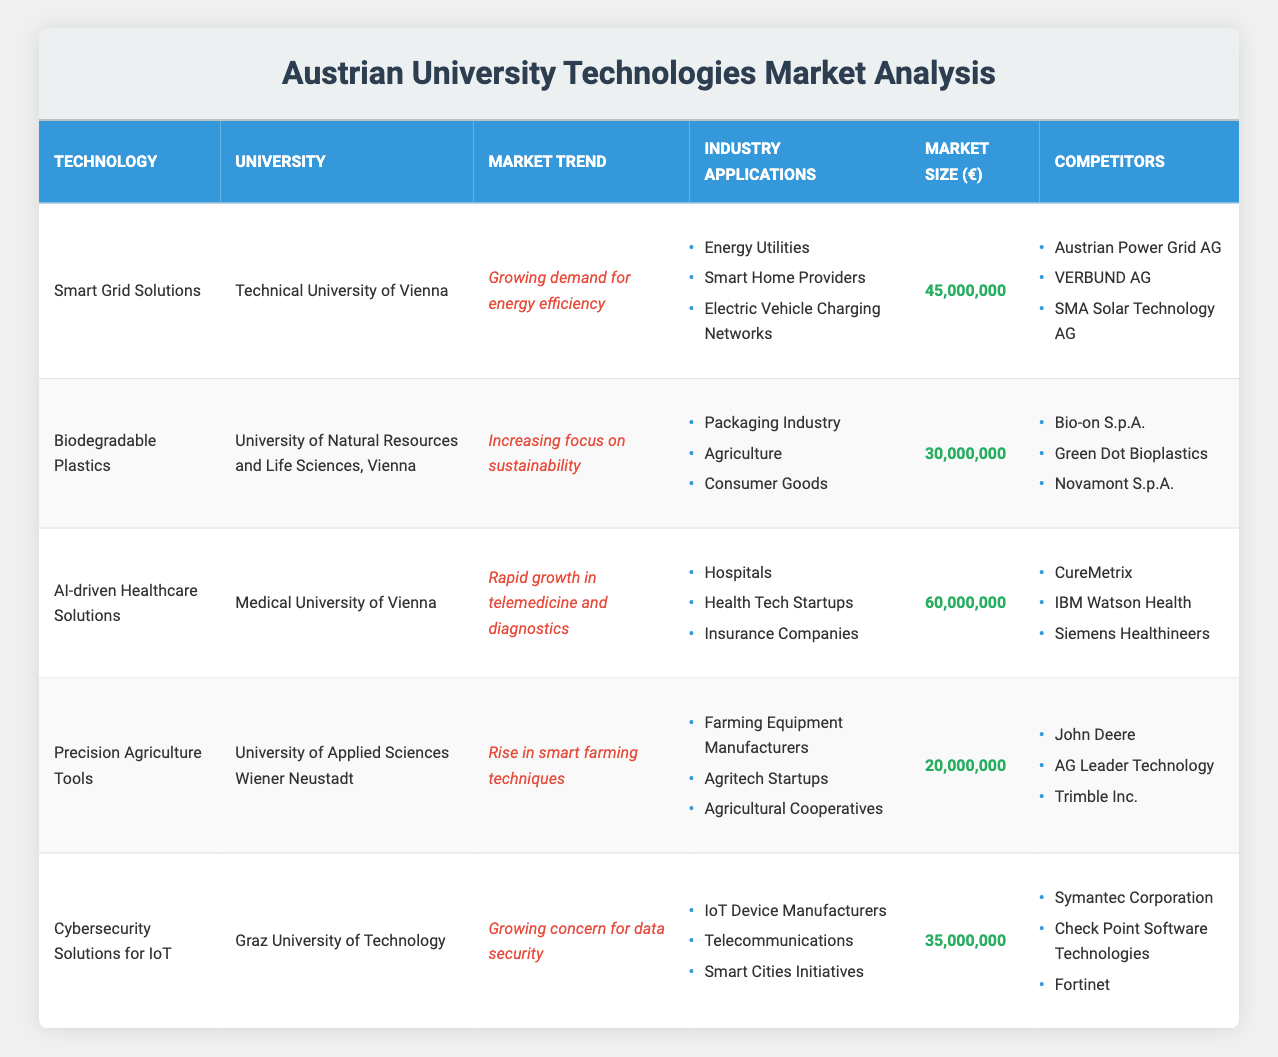What is the estimated market size for AI-driven Healthcare Solutions? The table indicates that the estimated market size for AI-driven Healthcare Solutions, associated with the Medical University of Vienna, is listed under the "Market Size (€)" column as 60,000,000 euros.
Answer: 60,000,000 Which technology has the highest estimated market size? By comparing the "Market Size (€)" values across all technologies, we find that AI-driven Healthcare Solutions has the highest estimated market size of 60,000,000 euros.
Answer: AI-driven Healthcare Solutions Is the market trend for Biodegradable Plastics focused on sustainability? Looking at the "Market Trend" column for Biodegradable Plastics, it specifies "Increasing focus on sustainability," confirming that the statement is true.
Answer: Yes How many competitors are listed for Cybersecurity Solutions for IoT? For Cybersecurity Solutions for IoT, there are three competitors listed under the "Competitors" column: Symantec Corporation, Check Point Software Technologies, and Fortinet, which means the answer is based on counting the entries.
Answer: 3 What is the total estimated market size of Smart Grid Solutions and Cybersecurity Solutions for IoT combined? To find the total, we take the estimated market sizes of both technologies: Smart Grid Solutions has 45,000,000 euros and Cybersecurity Solutions for IoT has 35,000,000 euros. Adding these together gives 45,000,000 + 35,000,000 = 80,000,000 euros.
Answer: 80,000,000 Which university is associated with Precision Agriculture Tools? The table clearly states that the University of Applied Sciences Wiener Neustadt is affiliated with Precision Agriculture Tools, as shown in the "University" column.
Answer: University of Applied Sciences Wiener Neustadt Does the technology "Smart Grid Solutions" relate to the "Smart Cities Initiatives" application? Reviewing the potential industry applications listed for Smart Grid Solutions, it includes Energy Utilities, Smart Home Providers, and Electric Vehicle Charging Networks, but not Smart Cities Initiatives. Therefore, the statement is false.
Answer: No What market trend correlates with Cybersecurity Solutions for IoT? The table indicates that the market trend for Cybersecurity Solutions for IoT is "Growing concern for data security" as shown in the "Market Trend" column.
Answer: Growing concern for data security Evaluate the average estimated market size of all technologies listed. To calculate the average, first sum the estimated market sizes: 45,000,000 + 30,000,000 + 60,000,000 + 20,000,000 + 35,000,000 = 190,000,000 euros. There are five technologies, so we divide this sum by 5: 190,000,000 / 5 = 38,000,000 euros.
Answer: 38,000,000 